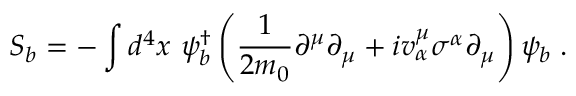Convert formula to latex. <formula><loc_0><loc_0><loc_500><loc_500>S _ { b } = - \int d ^ { 4 } x \psi _ { b } ^ { \dagger } \left ( \frac { 1 } { 2 m _ { 0 } } \partial ^ { \mu } \partial _ { \mu } + i v _ { \alpha } ^ { \mu } \sigma ^ { \alpha } \partial _ { \mu } \right ) \psi _ { b } \, .</formula> 